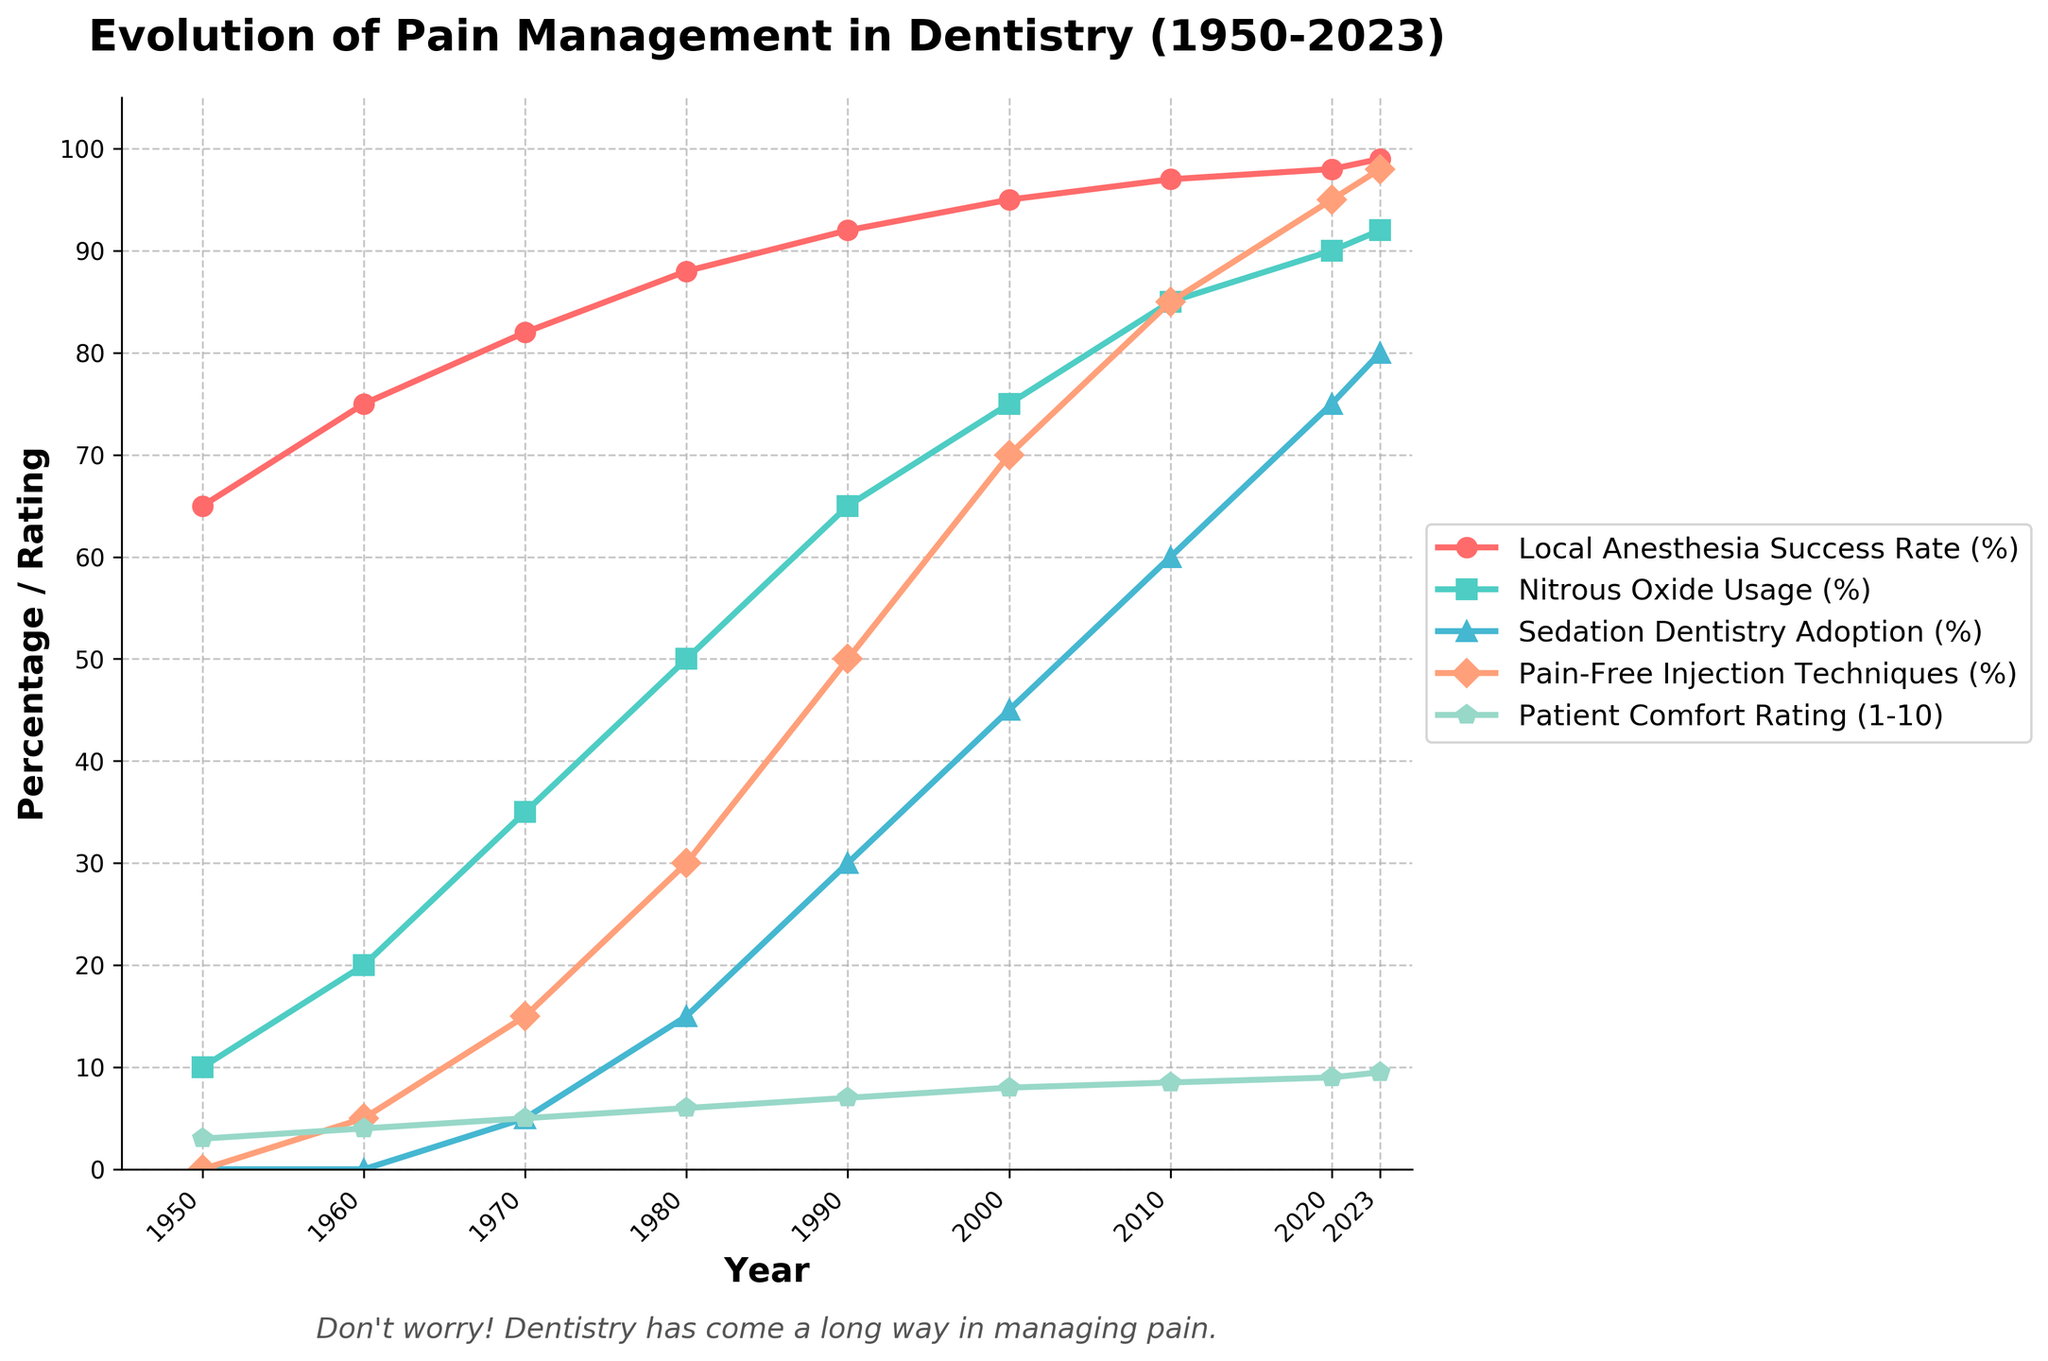What's the trend in Local Anesthesia Success Rate from 1950 to 2023? The Local Anesthesia Success Rate shows a steady increase from 65% in 1950 to 99% in 2023.
Answer: Steady increase How does the Patient Comfort Rating in 2023 compare to 1950? The Patient Comfort Rating in 2023 is significantly higher at 9.5 compared to 3 in 1950.
Answer: Higher in 2023 In what year did Nitrous Oxide Usage reach 50%? According to the figure, Nitrous Oxide Usage reached 50% in the year 1980.
Answer: 1980 Which technique had the most significant increase between 2000 and 2020? Pain-Free Injection Techniques had a notable increase from 70% in 2000 to 95% in 2020, the most significant among the techniques.
Answer: Pain-Free Injection Techniques What's the average Patient Comfort Rating between 2000 and 2023? The Patient Comfort Ratings from 2000, 2010, 2020, and 2023 are 8, 8.5, 9, and 9.5. The average is (8 + 8.5 + 9 + 9.5) / 4 = 8.75.
Answer: 8.75 Compare the Sedation Dentistry Adoption rate in 1990 and 2023. In 1990, Sedation Dentistry Adoption was 30%, and in 2023 it was 80%, showing a significant increase.
Answer: Significant increase What's the difference in Local Anesthesia Success Rate between 1960 and 2010? The Local Anesthesia Success Rates are 75% in 1960 and 97% in 2010. The difference is 97 - 75 = 22%.
Answer: 22% Which technique had the smallest change from 1980 to 2023? The Nitrous Oxide Usage increased from 50% in 1980 to 92% in 2023, which is more significant compared to other techniques.
Answer: Nitrous Oxide Usage How has the Patient Comfort Rating evolved from 1970 to 2023? The Patient Comfort Rating increased from 5 in 1970 to 9.5 in 2023, showing a consistent upward trend.
Answer: Consistent upward trend What's the ratio of Pain-Free Injection Techniques to Nitrous Oxide Usage in 2020? In 2020, Pain-Free Injection Techniques had a rate of 95%, and Nitrous Oxide Usage was at 90%. The ratio is 95/90 ≈ 1.056.
Answer: 1.056 